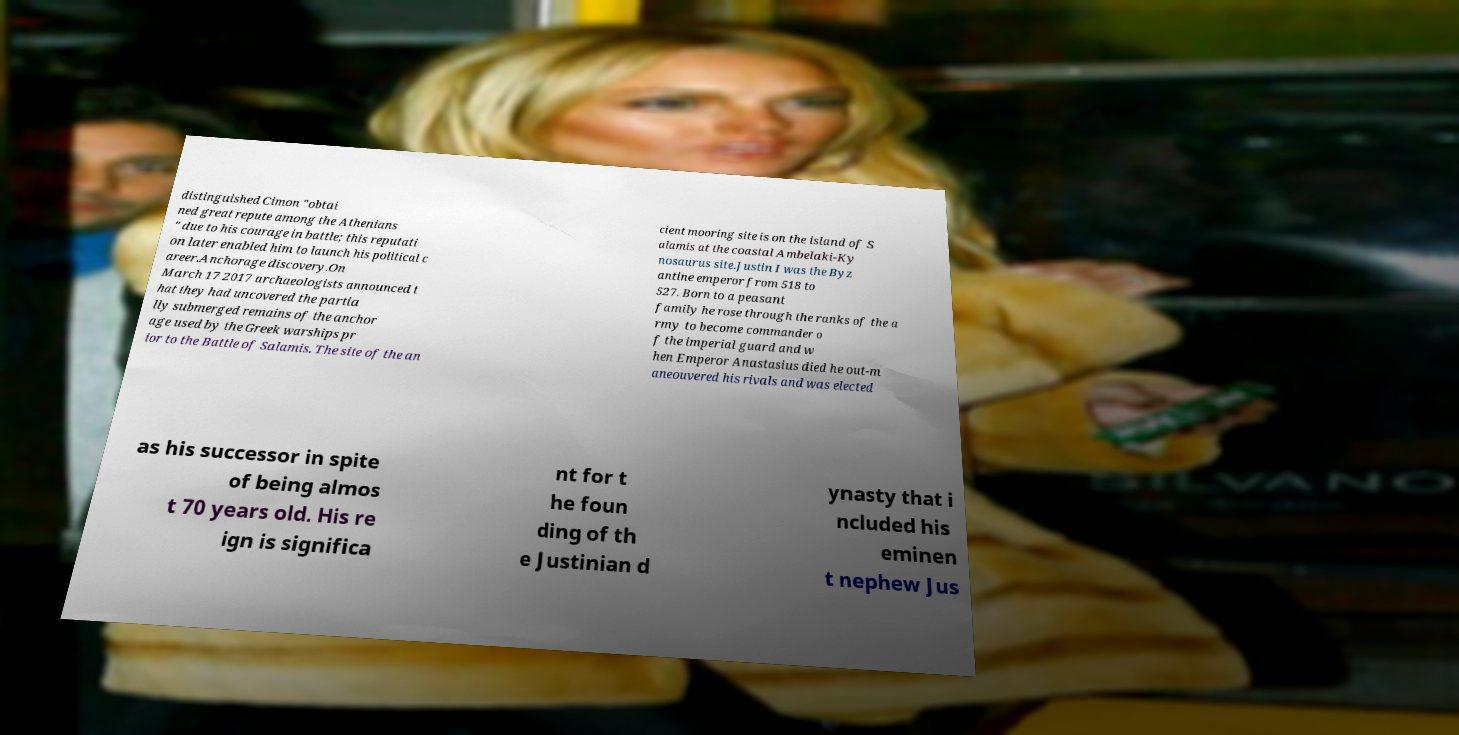Could you extract and type out the text from this image? distinguished Cimon "obtai ned great repute among the Athenians " due to his courage in battle; this reputati on later enabled him to launch his political c areer.Anchorage discovery.On March 17 2017 archaeologists announced t hat they had uncovered the partia lly submerged remains of the anchor age used by the Greek warships pr ior to the Battle of Salamis. The site of the an cient mooring site is on the island of S alamis at the coastal Ambelaki-Ky nosaurus site.Justin I was the Byz antine emperor from 518 to 527. Born to a peasant family he rose through the ranks of the a rmy to become commander o f the imperial guard and w hen Emperor Anastasius died he out-m aneouvered his rivals and was elected as his successor in spite of being almos t 70 years old. His re ign is significa nt for t he foun ding of th e Justinian d ynasty that i ncluded his eminen t nephew Jus 